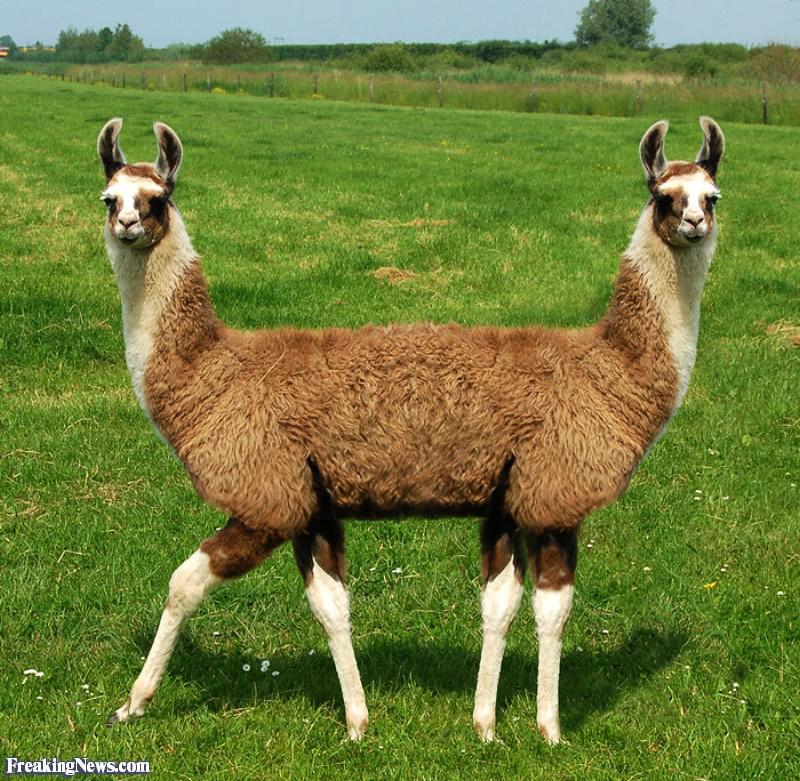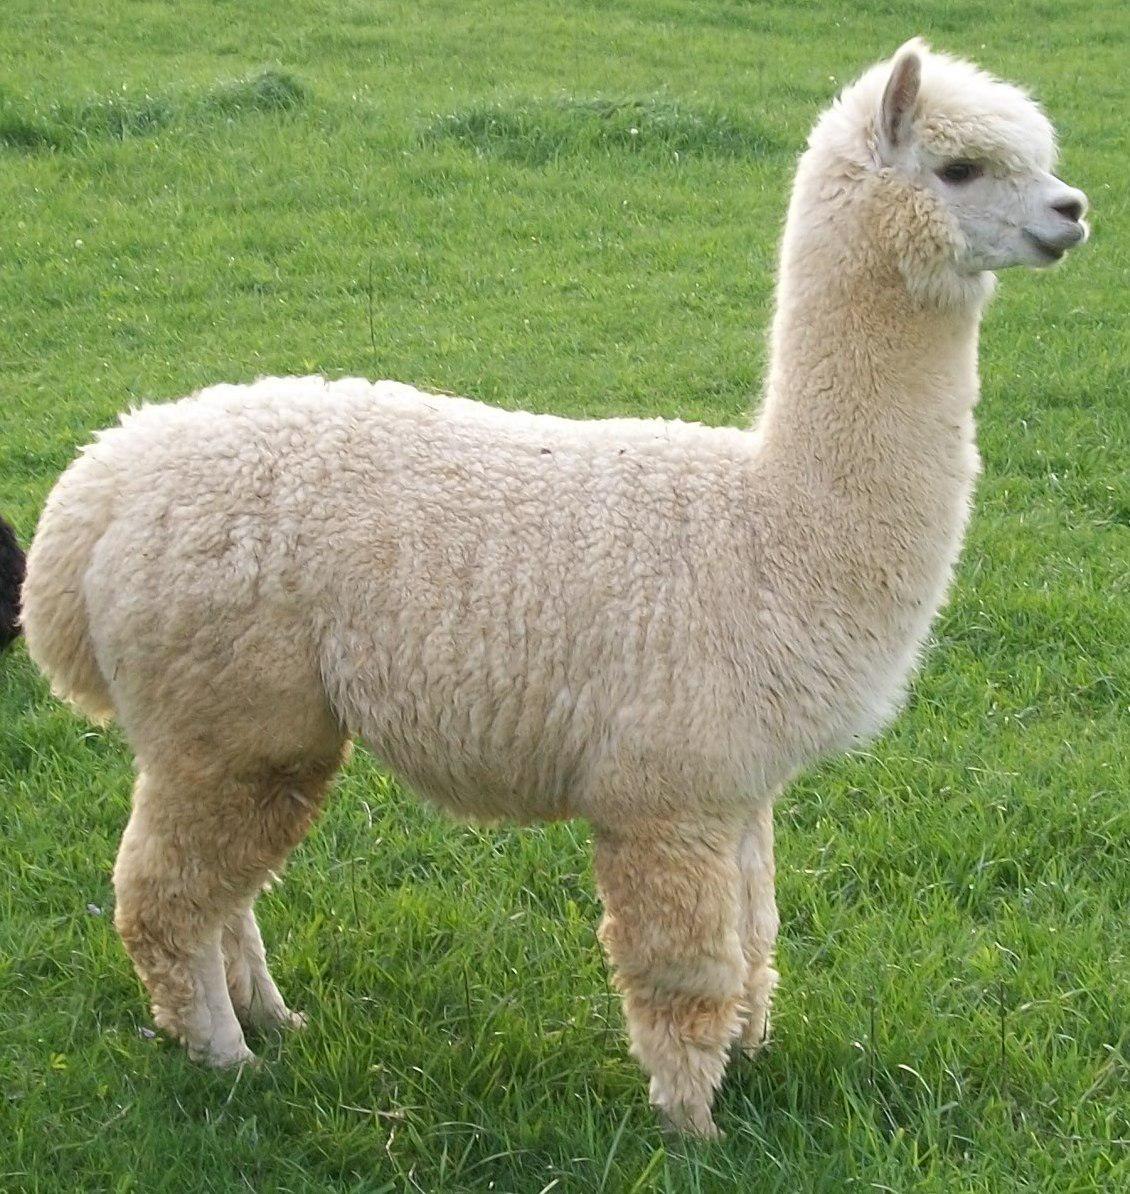The first image is the image on the left, the second image is the image on the right. Examine the images to the left and right. Is the description "The left and right image contains the same number of llamas." accurate? Answer yes or no. No. The first image is the image on the left, the second image is the image on the right. Evaluate the accuracy of this statement regarding the images: "An image features a white forward-facing llama showing its protruding lower teeth.". Is it true? Answer yes or no. No. 